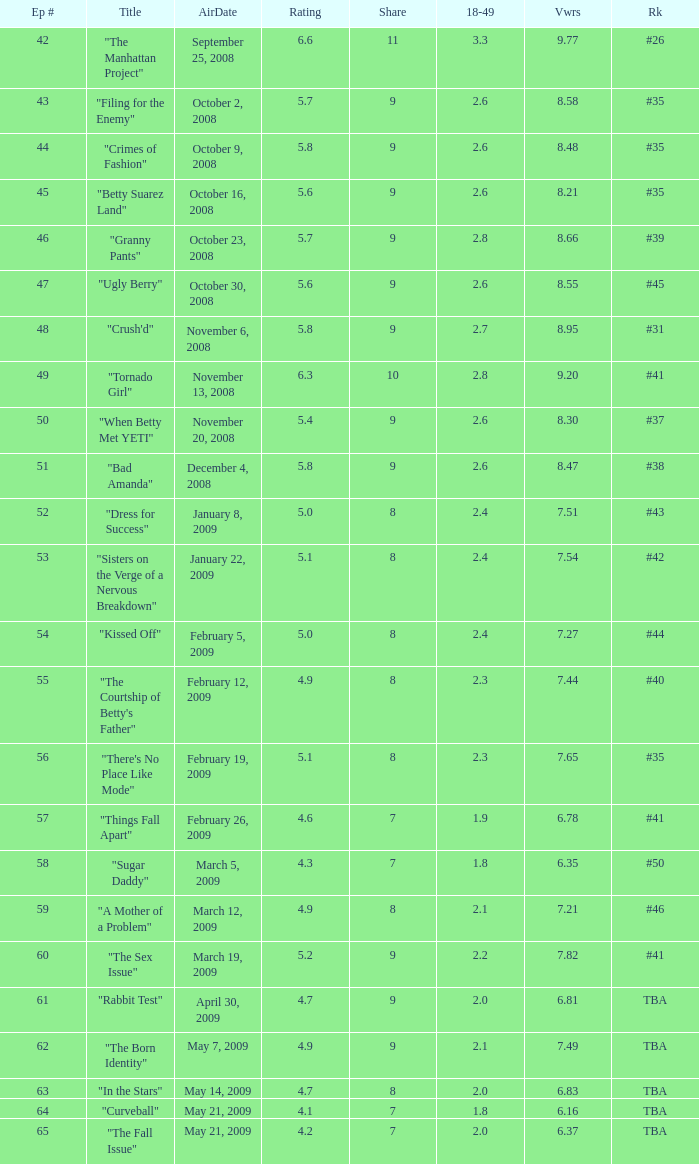What is the average Episode # with a 7 share and 18–49 is less than 2 and the Air Date of may 21, 2009? 64.0. 